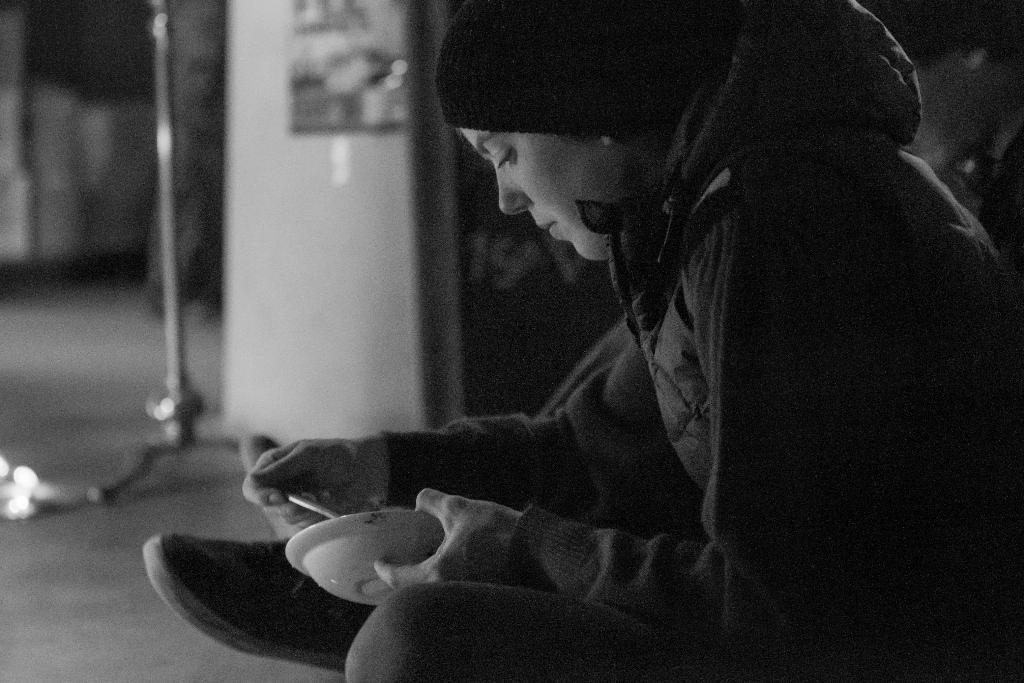In one or two sentences, can you explain what this image depicts? This is a black and white picture. In the foreground of the picture there is a person wearing a jacket and holding bowl. The background is blurred. Beside the woman there is a person. 